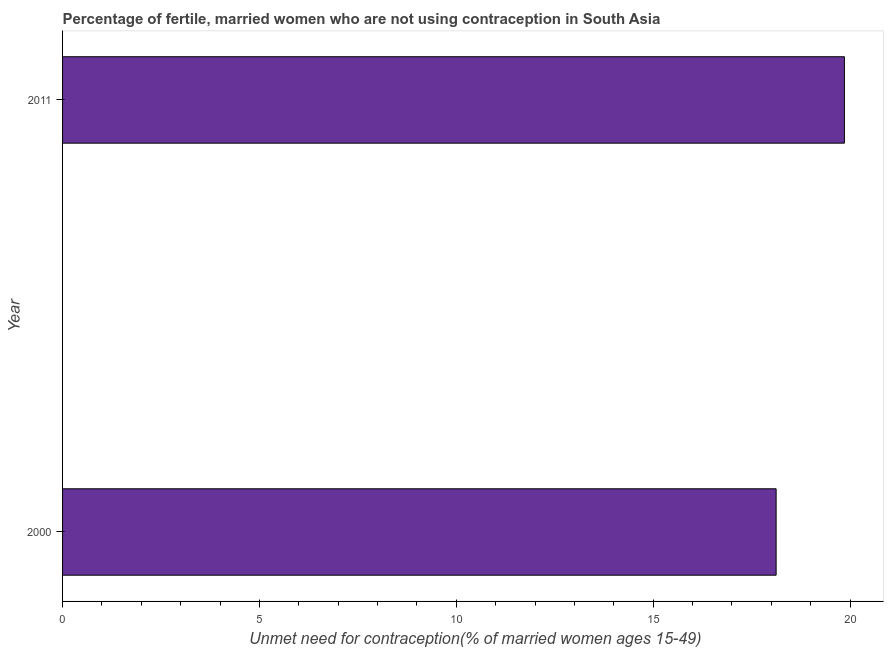Does the graph contain any zero values?
Ensure brevity in your answer.  No. Does the graph contain grids?
Your answer should be very brief. No. What is the title of the graph?
Make the answer very short. Percentage of fertile, married women who are not using contraception in South Asia. What is the label or title of the X-axis?
Make the answer very short.  Unmet need for contraception(% of married women ages 15-49). What is the number of married women who are not using contraception in 2000?
Your answer should be compact. 18.12. Across all years, what is the maximum number of married women who are not using contraception?
Your answer should be compact. 19.86. Across all years, what is the minimum number of married women who are not using contraception?
Your answer should be very brief. 18.12. In which year was the number of married women who are not using contraception minimum?
Offer a terse response. 2000. What is the sum of the number of married women who are not using contraception?
Make the answer very short. 37.98. What is the difference between the number of married women who are not using contraception in 2000 and 2011?
Offer a terse response. -1.73. What is the average number of married women who are not using contraception per year?
Your answer should be very brief. 18.99. What is the median number of married women who are not using contraception?
Offer a terse response. 18.99. Do a majority of the years between 2000 and 2011 (inclusive) have number of married women who are not using contraception greater than 2 %?
Your response must be concise. Yes. What is the ratio of the number of married women who are not using contraception in 2000 to that in 2011?
Your response must be concise. 0.91. Are all the bars in the graph horizontal?
Your response must be concise. Yes. How many years are there in the graph?
Provide a succinct answer. 2. What is the difference between two consecutive major ticks on the X-axis?
Provide a short and direct response. 5. Are the values on the major ticks of X-axis written in scientific E-notation?
Your response must be concise. No. What is the  Unmet need for contraception(% of married women ages 15-49) of 2000?
Your answer should be very brief. 18.12. What is the  Unmet need for contraception(% of married women ages 15-49) in 2011?
Your answer should be very brief. 19.86. What is the difference between the  Unmet need for contraception(% of married women ages 15-49) in 2000 and 2011?
Ensure brevity in your answer.  -1.73. What is the ratio of the  Unmet need for contraception(% of married women ages 15-49) in 2000 to that in 2011?
Offer a terse response. 0.91. 